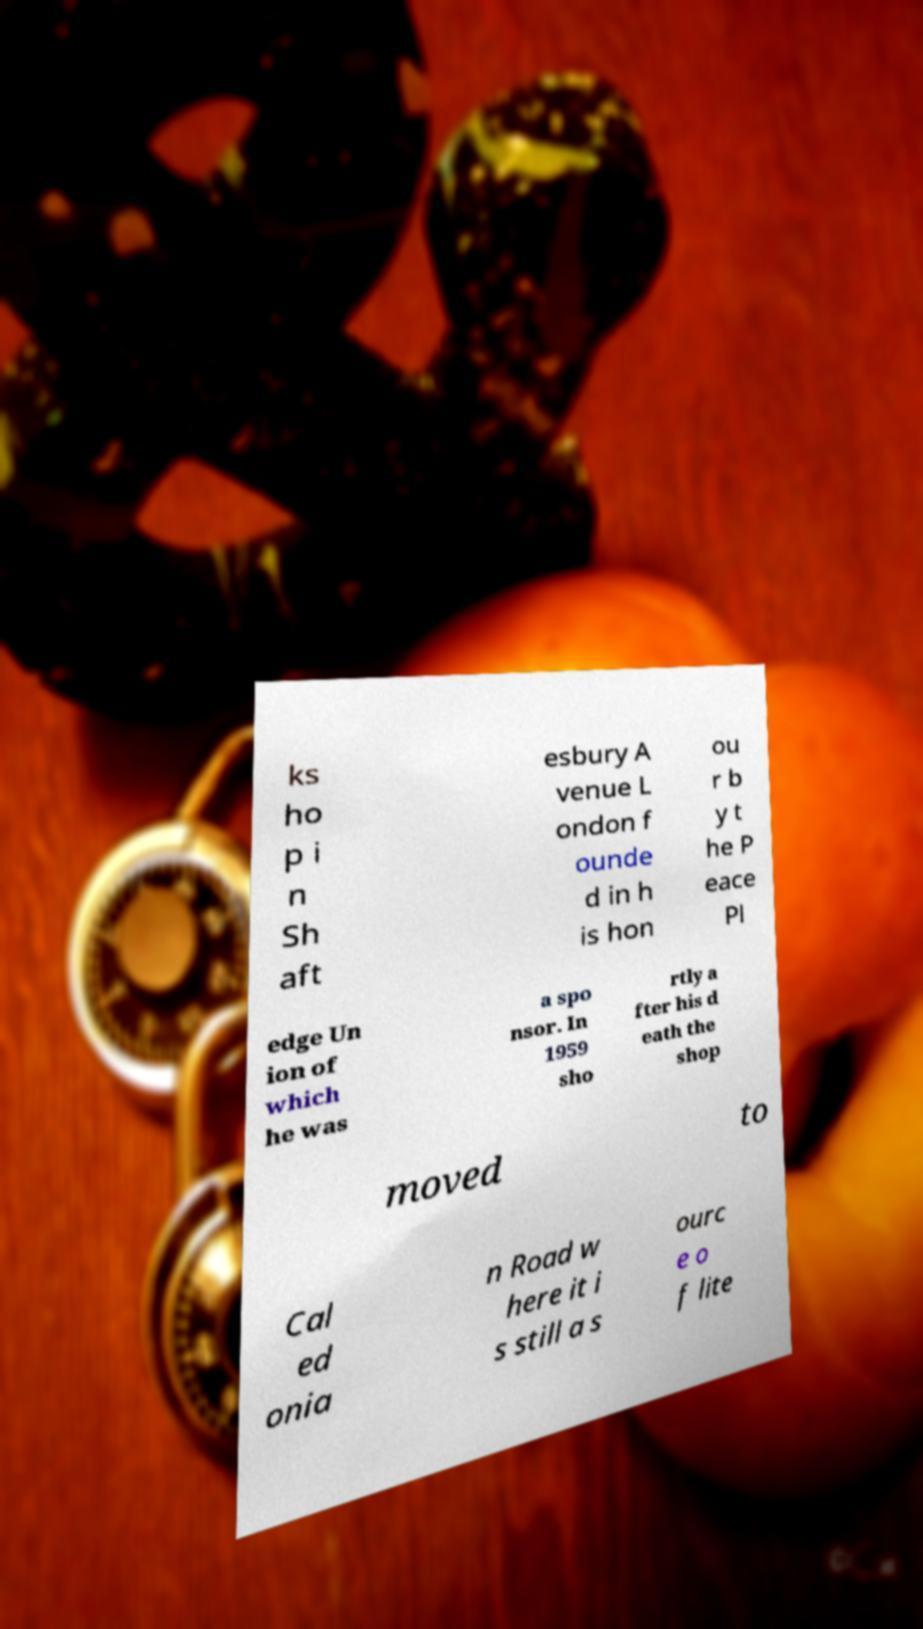I need the written content from this picture converted into text. Can you do that? ks ho p i n Sh aft esbury A venue L ondon f ounde d in h is hon ou r b y t he P eace Pl edge Un ion of which he was a spo nsor. In 1959 sho rtly a fter his d eath the shop moved to Cal ed onia n Road w here it i s still a s ourc e o f lite 